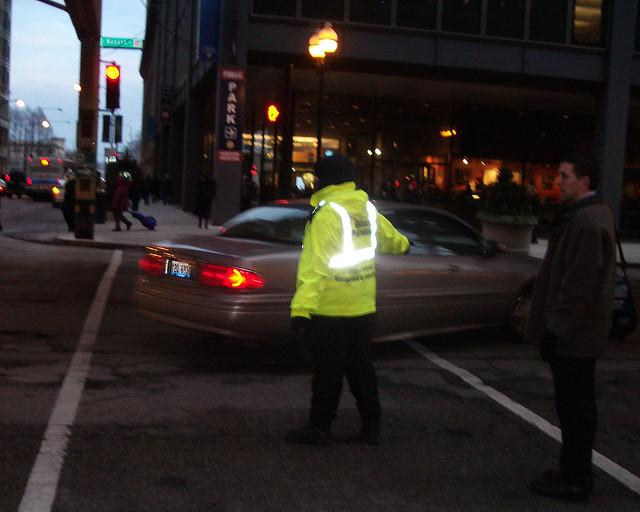Why is the man wearing a reflective jacket? visibility 